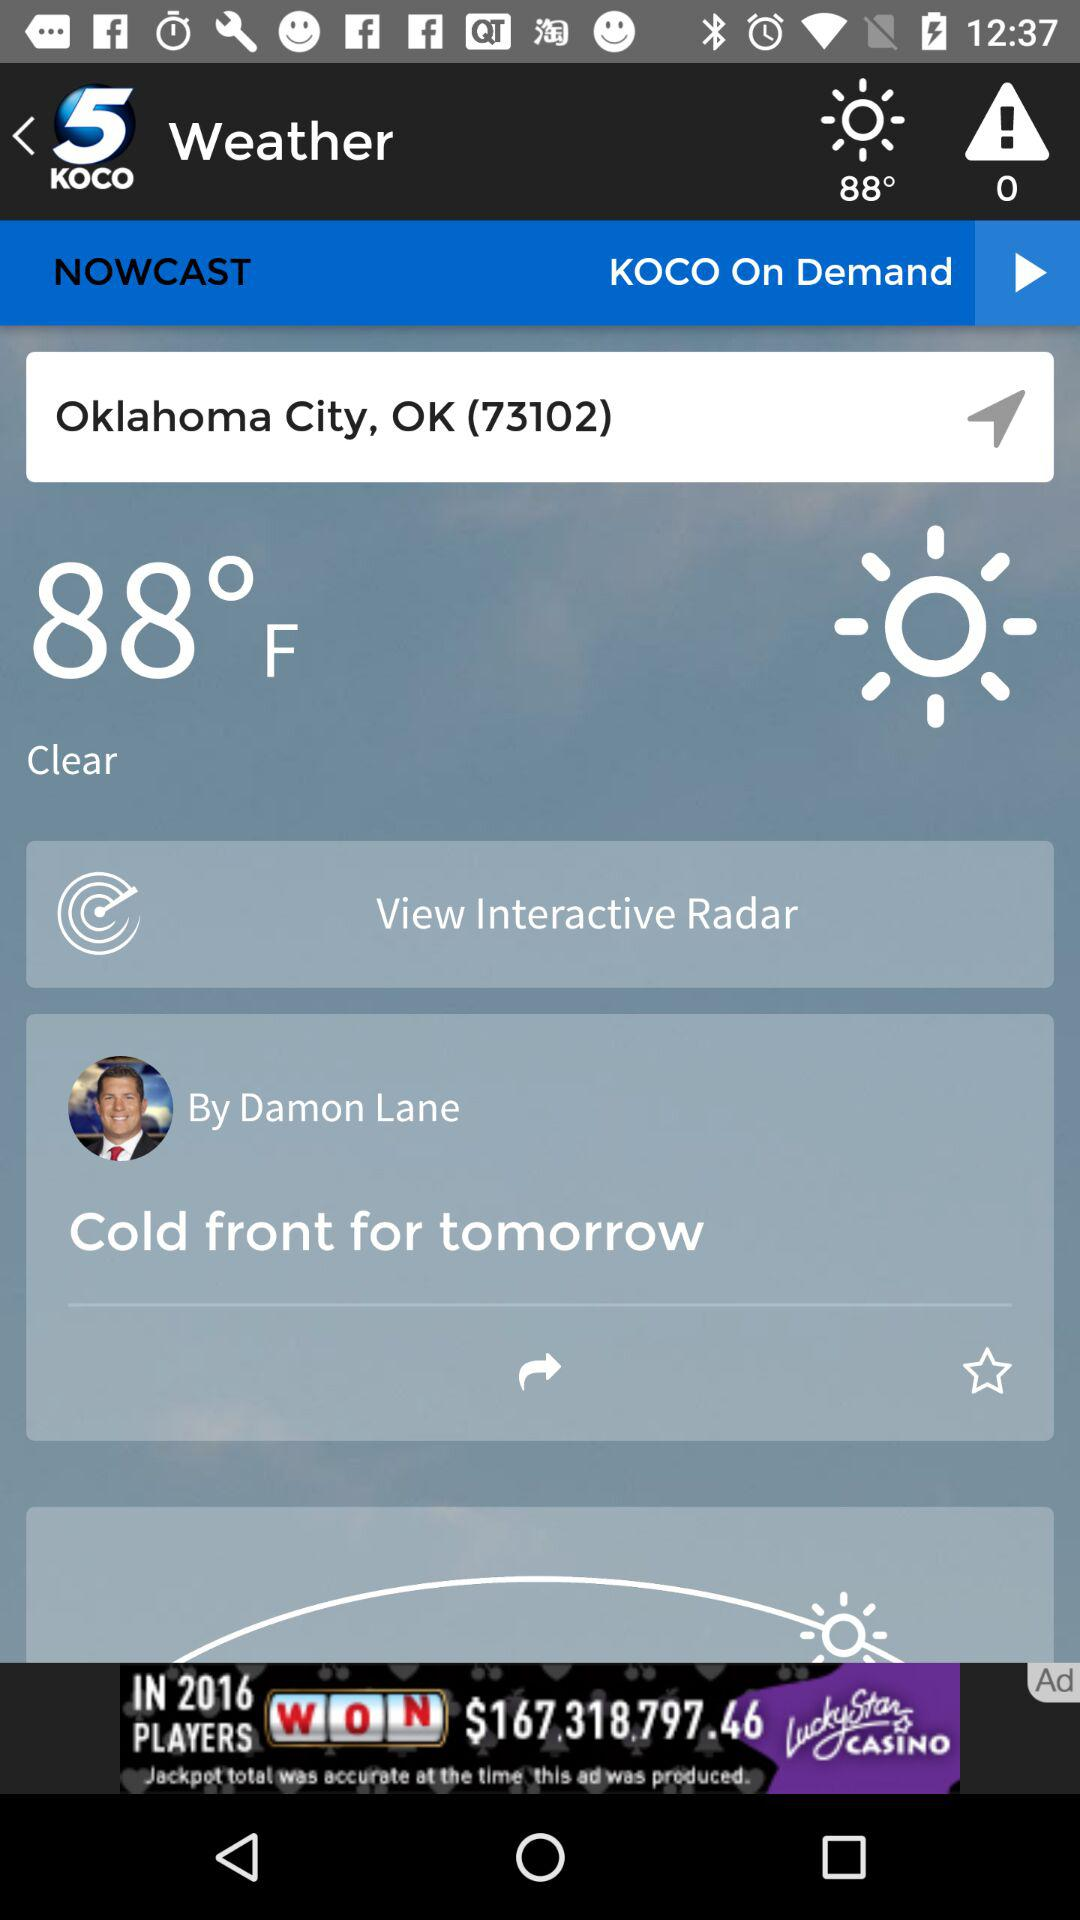What is the app name? The app name is "KOCO 5 News and Weather". 